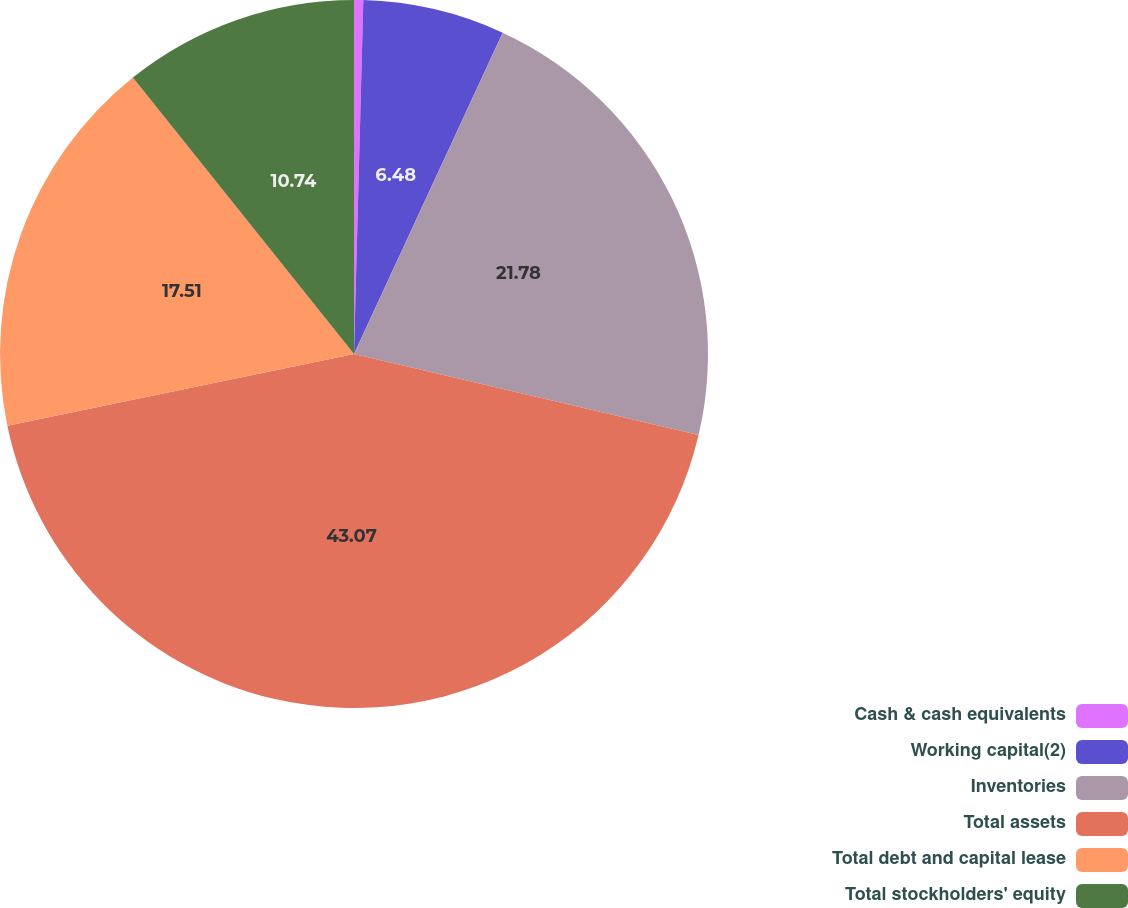<chart> <loc_0><loc_0><loc_500><loc_500><pie_chart><fcel>Cash & cash equivalents<fcel>Working capital(2)<fcel>Inventories<fcel>Total assets<fcel>Total debt and capital lease<fcel>Total stockholders' equity<nl><fcel>0.42%<fcel>6.48%<fcel>21.78%<fcel>43.07%<fcel>17.51%<fcel>10.74%<nl></chart> 